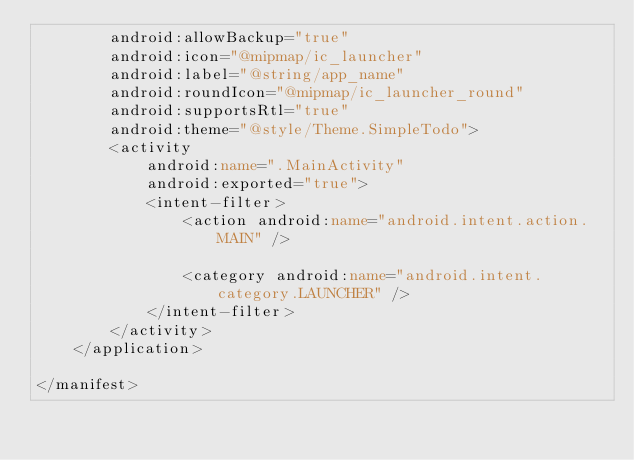Convert code to text. <code><loc_0><loc_0><loc_500><loc_500><_XML_>        android:allowBackup="true"
        android:icon="@mipmap/ic_launcher"
        android:label="@string/app_name"
        android:roundIcon="@mipmap/ic_launcher_round"
        android:supportsRtl="true"
        android:theme="@style/Theme.SimpleTodo">
        <activity
            android:name=".MainActivity"
            android:exported="true">
            <intent-filter>
                <action android:name="android.intent.action.MAIN" />

                <category android:name="android.intent.category.LAUNCHER" />
            </intent-filter>
        </activity>
    </application>

</manifest></code> 